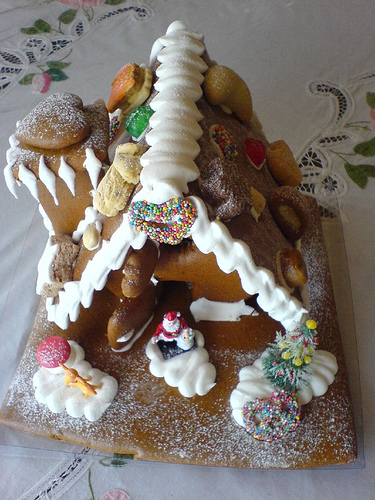<image>
Can you confirm if the heart is on the house? Yes. Looking at the image, I can see the heart is positioned on top of the house, with the house providing support. Is there a gingerbread house under the table? No. The gingerbread house is not positioned under the table. The vertical relationship between these objects is different. 